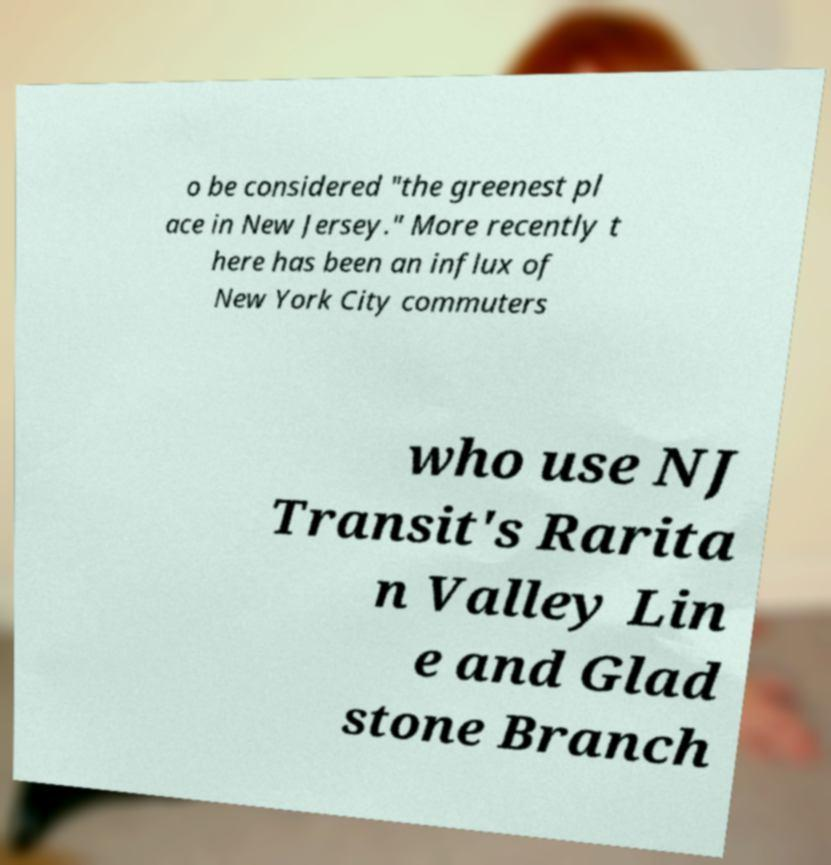Can you accurately transcribe the text from the provided image for me? o be considered "the greenest pl ace in New Jersey." More recently t here has been an influx of New York City commuters who use NJ Transit's Rarita n Valley Lin e and Glad stone Branch 